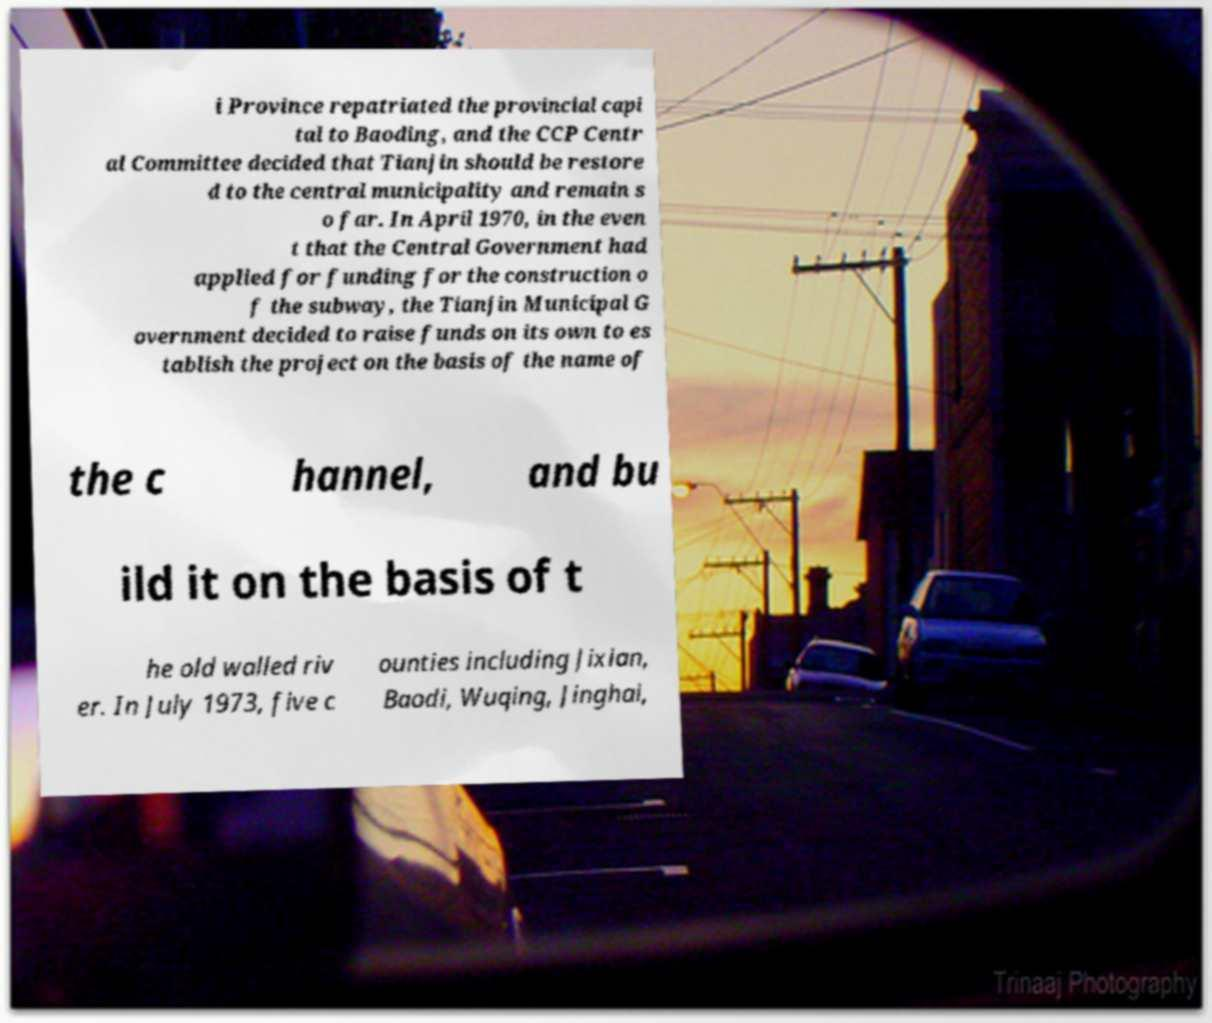Please read and relay the text visible in this image. What does it say? i Province repatriated the provincial capi tal to Baoding, and the CCP Centr al Committee decided that Tianjin should be restore d to the central municipality and remain s o far. In April 1970, in the even t that the Central Government had applied for funding for the construction o f the subway, the Tianjin Municipal G overnment decided to raise funds on its own to es tablish the project on the basis of the name of the c hannel, and bu ild it on the basis of t he old walled riv er. In July 1973, five c ounties including Jixian, Baodi, Wuqing, Jinghai, 